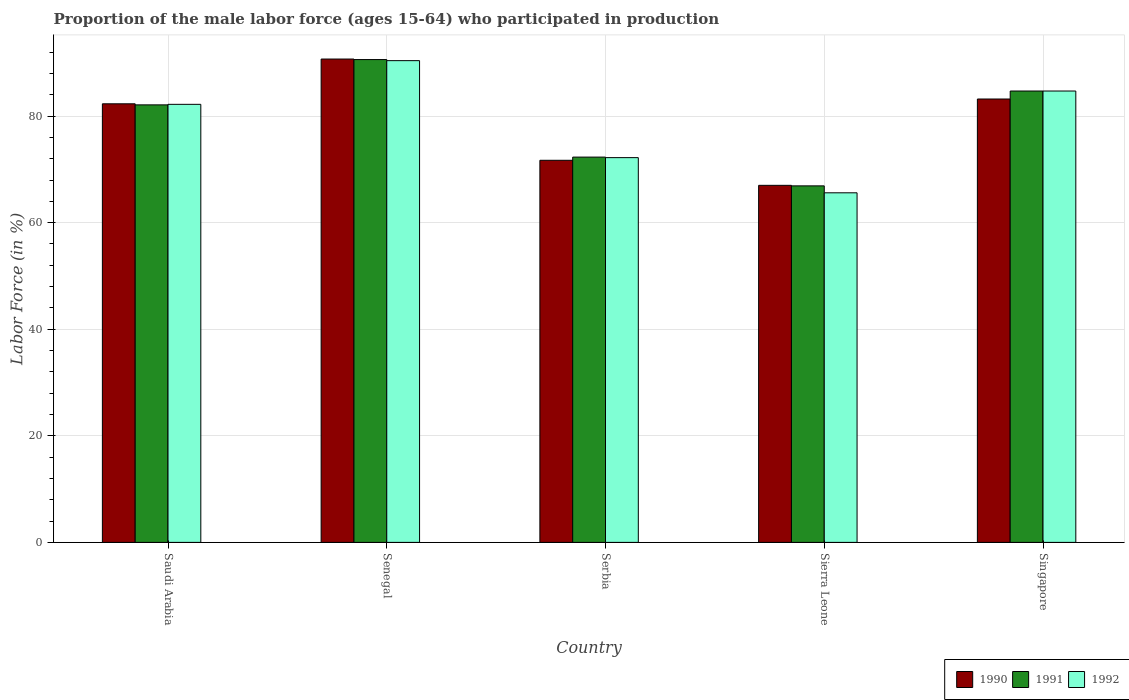How many groups of bars are there?
Your response must be concise. 5. What is the label of the 5th group of bars from the left?
Provide a succinct answer. Singapore. What is the proportion of the male labor force who participated in production in 1990 in Senegal?
Ensure brevity in your answer.  90.7. Across all countries, what is the maximum proportion of the male labor force who participated in production in 1990?
Your answer should be compact. 90.7. Across all countries, what is the minimum proportion of the male labor force who participated in production in 1991?
Your answer should be compact. 66.9. In which country was the proportion of the male labor force who participated in production in 1990 maximum?
Make the answer very short. Senegal. In which country was the proportion of the male labor force who participated in production in 1992 minimum?
Provide a short and direct response. Sierra Leone. What is the total proportion of the male labor force who participated in production in 1991 in the graph?
Your response must be concise. 396.6. What is the difference between the proportion of the male labor force who participated in production in 1990 in Saudi Arabia and that in Sierra Leone?
Ensure brevity in your answer.  15.3. What is the difference between the proportion of the male labor force who participated in production in 1992 in Saudi Arabia and the proportion of the male labor force who participated in production in 1990 in Sierra Leone?
Make the answer very short. 15.2. What is the average proportion of the male labor force who participated in production in 1991 per country?
Your answer should be very brief. 79.32. What is the ratio of the proportion of the male labor force who participated in production in 1991 in Saudi Arabia to that in Sierra Leone?
Provide a short and direct response. 1.23. Is the proportion of the male labor force who participated in production in 1992 in Senegal less than that in Sierra Leone?
Provide a succinct answer. No. What is the difference between the highest and the second highest proportion of the male labor force who participated in production in 1992?
Your answer should be compact. 5.7. What is the difference between the highest and the lowest proportion of the male labor force who participated in production in 1992?
Your answer should be compact. 24.8. In how many countries, is the proportion of the male labor force who participated in production in 1991 greater than the average proportion of the male labor force who participated in production in 1991 taken over all countries?
Provide a short and direct response. 3. What does the 2nd bar from the left in Senegal represents?
Offer a very short reply. 1991. Is it the case that in every country, the sum of the proportion of the male labor force who participated in production in 1990 and proportion of the male labor force who participated in production in 1991 is greater than the proportion of the male labor force who participated in production in 1992?
Your response must be concise. Yes. Are the values on the major ticks of Y-axis written in scientific E-notation?
Provide a succinct answer. No. Does the graph contain grids?
Keep it short and to the point. Yes. What is the title of the graph?
Offer a terse response. Proportion of the male labor force (ages 15-64) who participated in production. What is the label or title of the Y-axis?
Offer a terse response. Labor Force (in %). What is the Labor Force (in %) in 1990 in Saudi Arabia?
Provide a succinct answer. 82.3. What is the Labor Force (in %) in 1991 in Saudi Arabia?
Give a very brief answer. 82.1. What is the Labor Force (in %) in 1992 in Saudi Arabia?
Your answer should be compact. 82.2. What is the Labor Force (in %) in 1990 in Senegal?
Offer a terse response. 90.7. What is the Labor Force (in %) of 1991 in Senegal?
Your answer should be compact. 90.6. What is the Labor Force (in %) of 1992 in Senegal?
Offer a very short reply. 90.4. What is the Labor Force (in %) in 1990 in Serbia?
Keep it short and to the point. 71.7. What is the Labor Force (in %) of 1991 in Serbia?
Offer a very short reply. 72.3. What is the Labor Force (in %) of 1992 in Serbia?
Make the answer very short. 72.2. What is the Labor Force (in %) of 1990 in Sierra Leone?
Your answer should be very brief. 67. What is the Labor Force (in %) in 1991 in Sierra Leone?
Your answer should be very brief. 66.9. What is the Labor Force (in %) of 1992 in Sierra Leone?
Offer a very short reply. 65.6. What is the Labor Force (in %) in 1990 in Singapore?
Your response must be concise. 83.2. What is the Labor Force (in %) of 1991 in Singapore?
Offer a very short reply. 84.7. What is the Labor Force (in %) of 1992 in Singapore?
Keep it short and to the point. 84.7. Across all countries, what is the maximum Labor Force (in %) of 1990?
Offer a terse response. 90.7. Across all countries, what is the maximum Labor Force (in %) in 1991?
Make the answer very short. 90.6. Across all countries, what is the maximum Labor Force (in %) in 1992?
Offer a terse response. 90.4. Across all countries, what is the minimum Labor Force (in %) of 1991?
Your response must be concise. 66.9. Across all countries, what is the minimum Labor Force (in %) in 1992?
Provide a succinct answer. 65.6. What is the total Labor Force (in %) in 1990 in the graph?
Keep it short and to the point. 394.9. What is the total Labor Force (in %) of 1991 in the graph?
Provide a short and direct response. 396.6. What is the total Labor Force (in %) in 1992 in the graph?
Provide a succinct answer. 395.1. What is the difference between the Labor Force (in %) in 1992 in Saudi Arabia and that in Senegal?
Make the answer very short. -8.2. What is the difference between the Labor Force (in %) of 1990 in Saudi Arabia and that in Serbia?
Ensure brevity in your answer.  10.6. What is the difference between the Labor Force (in %) of 1992 in Saudi Arabia and that in Serbia?
Your answer should be compact. 10. What is the difference between the Labor Force (in %) of 1990 in Saudi Arabia and that in Sierra Leone?
Offer a terse response. 15.3. What is the difference between the Labor Force (in %) in 1990 in Saudi Arabia and that in Singapore?
Make the answer very short. -0.9. What is the difference between the Labor Force (in %) in 1991 in Saudi Arabia and that in Singapore?
Offer a terse response. -2.6. What is the difference between the Labor Force (in %) of 1991 in Senegal and that in Serbia?
Keep it short and to the point. 18.3. What is the difference between the Labor Force (in %) of 1990 in Senegal and that in Sierra Leone?
Keep it short and to the point. 23.7. What is the difference between the Labor Force (in %) of 1991 in Senegal and that in Sierra Leone?
Make the answer very short. 23.7. What is the difference between the Labor Force (in %) in 1992 in Senegal and that in Sierra Leone?
Your answer should be compact. 24.8. What is the difference between the Labor Force (in %) in 1990 in Senegal and that in Singapore?
Your answer should be very brief. 7.5. What is the difference between the Labor Force (in %) of 1991 in Senegal and that in Singapore?
Give a very brief answer. 5.9. What is the difference between the Labor Force (in %) in 1992 in Senegal and that in Singapore?
Your answer should be very brief. 5.7. What is the difference between the Labor Force (in %) in 1990 in Serbia and that in Singapore?
Ensure brevity in your answer.  -11.5. What is the difference between the Labor Force (in %) in 1991 in Serbia and that in Singapore?
Make the answer very short. -12.4. What is the difference between the Labor Force (in %) of 1992 in Serbia and that in Singapore?
Your response must be concise. -12.5. What is the difference between the Labor Force (in %) in 1990 in Sierra Leone and that in Singapore?
Ensure brevity in your answer.  -16.2. What is the difference between the Labor Force (in %) in 1991 in Sierra Leone and that in Singapore?
Your response must be concise. -17.8. What is the difference between the Labor Force (in %) in 1992 in Sierra Leone and that in Singapore?
Your answer should be very brief. -19.1. What is the difference between the Labor Force (in %) in 1990 in Saudi Arabia and the Labor Force (in %) in 1991 in Senegal?
Offer a very short reply. -8.3. What is the difference between the Labor Force (in %) of 1990 in Saudi Arabia and the Labor Force (in %) of 1992 in Senegal?
Make the answer very short. -8.1. What is the difference between the Labor Force (in %) in 1991 in Saudi Arabia and the Labor Force (in %) in 1992 in Senegal?
Your answer should be compact. -8.3. What is the difference between the Labor Force (in %) in 1990 in Saudi Arabia and the Labor Force (in %) in 1991 in Serbia?
Provide a short and direct response. 10. What is the difference between the Labor Force (in %) in 1990 in Saudi Arabia and the Labor Force (in %) in 1991 in Sierra Leone?
Ensure brevity in your answer.  15.4. What is the difference between the Labor Force (in %) of 1990 in Saudi Arabia and the Labor Force (in %) of 1992 in Sierra Leone?
Provide a succinct answer. 16.7. What is the difference between the Labor Force (in %) in 1990 in Saudi Arabia and the Labor Force (in %) in 1992 in Singapore?
Make the answer very short. -2.4. What is the difference between the Labor Force (in %) of 1991 in Saudi Arabia and the Labor Force (in %) of 1992 in Singapore?
Offer a very short reply. -2.6. What is the difference between the Labor Force (in %) in 1990 in Senegal and the Labor Force (in %) in 1991 in Serbia?
Provide a short and direct response. 18.4. What is the difference between the Labor Force (in %) in 1990 in Senegal and the Labor Force (in %) in 1992 in Serbia?
Make the answer very short. 18.5. What is the difference between the Labor Force (in %) of 1990 in Senegal and the Labor Force (in %) of 1991 in Sierra Leone?
Provide a succinct answer. 23.8. What is the difference between the Labor Force (in %) of 1990 in Senegal and the Labor Force (in %) of 1992 in Sierra Leone?
Make the answer very short. 25.1. What is the difference between the Labor Force (in %) in 1990 in Senegal and the Labor Force (in %) in 1991 in Singapore?
Provide a short and direct response. 6. What is the difference between the Labor Force (in %) of 1991 in Senegal and the Labor Force (in %) of 1992 in Singapore?
Provide a succinct answer. 5.9. What is the difference between the Labor Force (in %) of 1990 in Serbia and the Labor Force (in %) of 1991 in Singapore?
Keep it short and to the point. -13. What is the difference between the Labor Force (in %) in 1990 in Serbia and the Labor Force (in %) in 1992 in Singapore?
Your response must be concise. -13. What is the difference between the Labor Force (in %) of 1990 in Sierra Leone and the Labor Force (in %) of 1991 in Singapore?
Ensure brevity in your answer.  -17.7. What is the difference between the Labor Force (in %) in 1990 in Sierra Leone and the Labor Force (in %) in 1992 in Singapore?
Your answer should be very brief. -17.7. What is the difference between the Labor Force (in %) in 1991 in Sierra Leone and the Labor Force (in %) in 1992 in Singapore?
Make the answer very short. -17.8. What is the average Labor Force (in %) in 1990 per country?
Offer a terse response. 78.98. What is the average Labor Force (in %) in 1991 per country?
Give a very brief answer. 79.32. What is the average Labor Force (in %) of 1992 per country?
Offer a very short reply. 79.02. What is the difference between the Labor Force (in %) in 1990 and Labor Force (in %) in 1991 in Saudi Arabia?
Offer a very short reply. 0.2. What is the difference between the Labor Force (in %) of 1991 and Labor Force (in %) of 1992 in Senegal?
Your response must be concise. 0.2. What is the difference between the Labor Force (in %) of 1990 and Labor Force (in %) of 1991 in Serbia?
Offer a terse response. -0.6. What is the difference between the Labor Force (in %) of 1990 and Labor Force (in %) of 1991 in Sierra Leone?
Ensure brevity in your answer.  0.1. What is the difference between the Labor Force (in %) of 1991 and Labor Force (in %) of 1992 in Sierra Leone?
Your answer should be very brief. 1.3. What is the difference between the Labor Force (in %) in 1990 and Labor Force (in %) in 1991 in Singapore?
Offer a very short reply. -1.5. What is the difference between the Labor Force (in %) of 1990 and Labor Force (in %) of 1992 in Singapore?
Offer a very short reply. -1.5. What is the ratio of the Labor Force (in %) in 1990 in Saudi Arabia to that in Senegal?
Your response must be concise. 0.91. What is the ratio of the Labor Force (in %) of 1991 in Saudi Arabia to that in Senegal?
Offer a very short reply. 0.91. What is the ratio of the Labor Force (in %) in 1992 in Saudi Arabia to that in Senegal?
Offer a very short reply. 0.91. What is the ratio of the Labor Force (in %) in 1990 in Saudi Arabia to that in Serbia?
Provide a succinct answer. 1.15. What is the ratio of the Labor Force (in %) in 1991 in Saudi Arabia to that in Serbia?
Ensure brevity in your answer.  1.14. What is the ratio of the Labor Force (in %) of 1992 in Saudi Arabia to that in Serbia?
Your response must be concise. 1.14. What is the ratio of the Labor Force (in %) in 1990 in Saudi Arabia to that in Sierra Leone?
Your response must be concise. 1.23. What is the ratio of the Labor Force (in %) in 1991 in Saudi Arabia to that in Sierra Leone?
Provide a succinct answer. 1.23. What is the ratio of the Labor Force (in %) in 1992 in Saudi Arabia to that in Sierra Leone?
Your response must be concise. 1.25. What is the ratio of the Labor Force (in %) of 1990 in Saudi Arabia to that in Singapore?
Give a very brief answer. 0.99. What is the ratio of the Labor Force (in %) of 1991 in Saudi Arabia to that in Singapore?
Give a very brief answer. 0.97. What is the ratio of the Labor Force (in %) of 1992 in Saudi Arabia to that in Singapore?
Provide a succinct answer. 0.97. What is the ratio of the Labor Force (in %) in 1990 in Senegal to that in Serbia?
Keep it short and to the point. 1.26. What is the ratio of the Labor Force (in %) in 1991 in Senegal to that in Serbia?
Give a very brief answer. 1.25. What is the ratio of the Labor Force (in %) of 1992 in Senegal to that in Serbia?
Your response must be concise. 1.25. What is the ratio of the Labor Force (in %) of 1990 in Senegal to that in Sierra Leone?
Make the answer very short. 1.35. What is the ratio of the Labor Force (in %) in 1991 in Senegal to that in Sierra Leone?
Give a very brief answer. 1.35. What is the ratio of the Labor Force (in %) in 1992 in Senegal to that in Sierra Leone?
Offer a terse response. 1.38. What is the ratio of the Labor Force (in %) in 1990 in Senegal to that in Singapore?
Keep it short and to the point. 1.09. What is the ratio of the Labor Force (in %) of 1991 in Senegal to that in Singapore?
Give a very brief answer. 1.07. What is the ratio of the Labor Force (in %) of 1992 in Senegal to that in Singapore?
Keep it short and to the point. 1.07. What is the ratio of the Labor Force (in %) of 1990 in Serbia to that in Sierra Leone?
Your answer should be compact. 1.07. What is the ratio of the Labor Force (in %) of 1991 in Serbia to that in Sierra Leone?
Keep it short and to the point. 1.08. What is the ratio of the Labor Force (in %) of 1992 in Serbia to that in Sierra Leone?
Make the answer very short. 1.1. What is the ratio of the Labor Force (in %) of 1990 in Serbia to that in Singapore?
Ensure brevity in your answer.  0.86. What is the ratio of the Labor Force (in %) in 1991 in Serbia to that in Singapore?
Offer a terse response. 0.85. What is the ratio of the Labor Force (in %) of 1992 in Serbia to that in Singapore?
Provide a short and direct response. 0.85. What is the ratio of the Labor Force (in %) in 1990 in Sierra Leone to that in Singapore?
Your answer should be very brief. 0.81. What is the ratio of the Labor Force (in %) in 1991 in Sierra Leone to that in Singapore?
Your response must be concise. 0.79. What is the ratio of the Labor Force (in %) in 1992 in Sierra Leone to that in Singapore?
Offer a very short reply. 0.77. What is the difference between the highest and the second highest Labor Force (in %) in 1991?
Ensure brevity in your answer.  5.9. What is the difference between the highest and the second highest Labor Force (in %) in 1992?
Keep it short and to the point. 5.7. What is the difference between the highest and the lowest Labor Force (in %) in 1990?
Your answer should be very brief. 23.7. What is the difference between the highest and the lowest Labor Force (in %) in 1991?
Your answer should be very brief. 23.7. What is the difference between the highest and the lowest Labor Force (in %) of 1992?
Give a very brief answer. 24.8. 